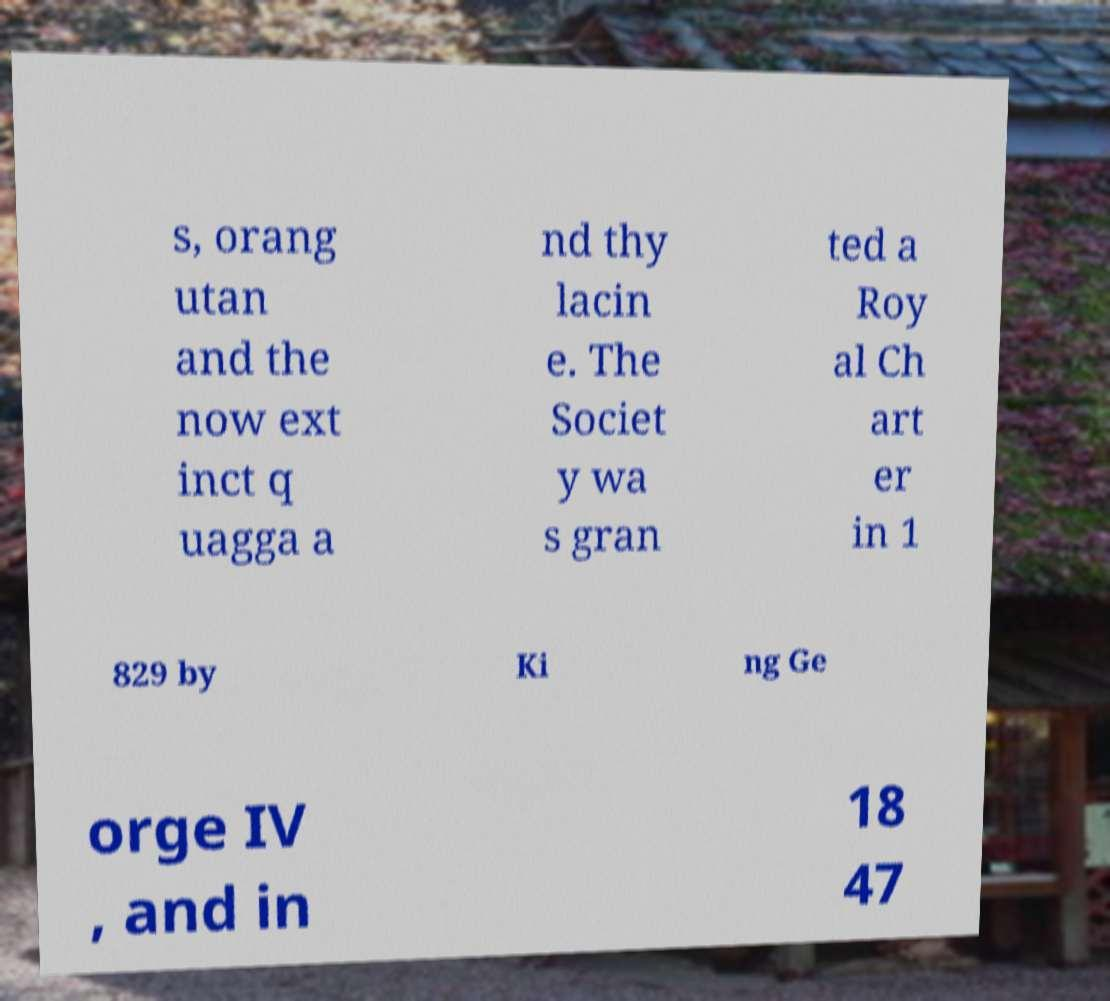Could you assist in decoding the text presented in this image and type it out clearly? s, orang utan and the now ext inct q uagga a nd thy lacin e. The Societ y wa s gran ted a Roy al Ch art er in 1 829 by Ki ng Ge orge IV , and in 18 47 